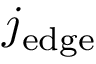<formula> <loc_0><loc_0><loc_500><loc_500>j _ { e d g e }</formula> 